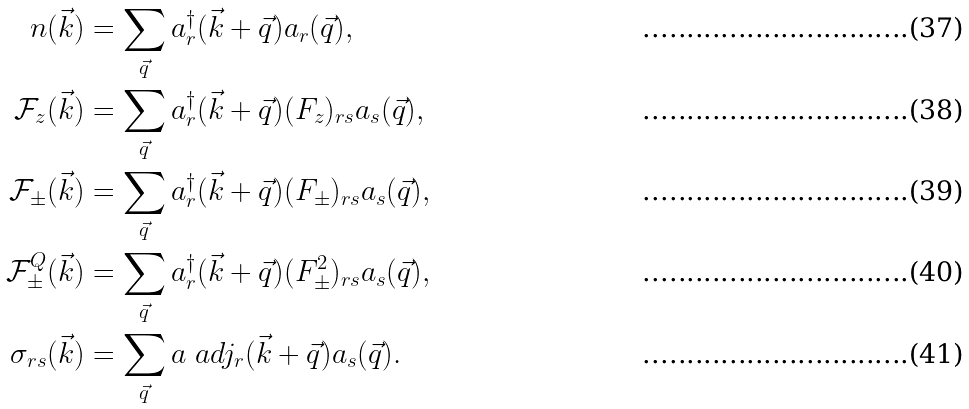Convert formula to latex. <formula><loc_0><loc_0><loc_500><loc_500>n ( \vec { k } ) & = \sum _ { \vec { q } } a ^ { \dagger } _ { r } ( \vec { k } + \vec { q } ) a _ { r } ( \vec { q } ) , \\ { \mathcal { F } } _ { z } ( \vec { k } ) & = \sum _ { \vec { q } } a ^ { \dagger } _ { r } ( \vec { k } + \vec { q } ) ( F _ { z } ) _ { r s } a _ { s } ( \vec { q } ) , \\ { \mathcal { F } } _ { \pm } ( \vec { k } ) & = \sum _ { \vec { q } } a ^ { \dagger } _ { r } ( \vec { k } + \vec { q } ) ( F _ { \pm } ) _ { r s } a _ { s } ( \vec { q } ) , \\ { \mathcal { F } } ^ { Q } _ { \pm } ( \vec { k } ) & = \sum _ { \vec { q } } a ^ { \dagger } _ { r } ( \vec { k } + \vec { q } ) ( F _ { \pm } ^ { 2 } ) _ { r s } a _ { s } ( \vec { q } ) , \\ \sigma _ { r s } ( \vec { k } ) & = \sum _ { \vec { q } } a \ a d j _ { r } ( \vec { k } + \vec { q } ) a _ { s } ( \vec { q } ) .</formula> 